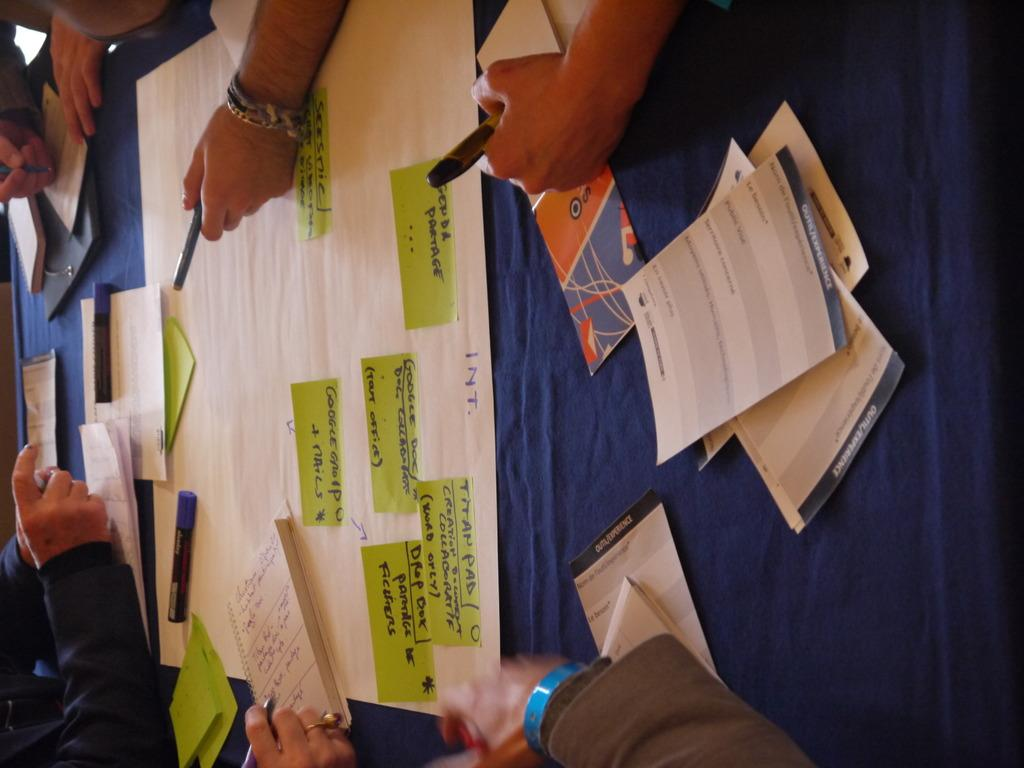How many people are in the image? There are people in the image, but the exact number is not specified. What are the people holding in their hands? The people are holding pens in their hands. What else can be seen in the image besides the people and pens? There are papers, books, and other objects on a board in the image. What type of bottle can be seen on the board in the image? There is no bottle present on the board in the image. What material is the train made of in the image? There is no train present in the image. 